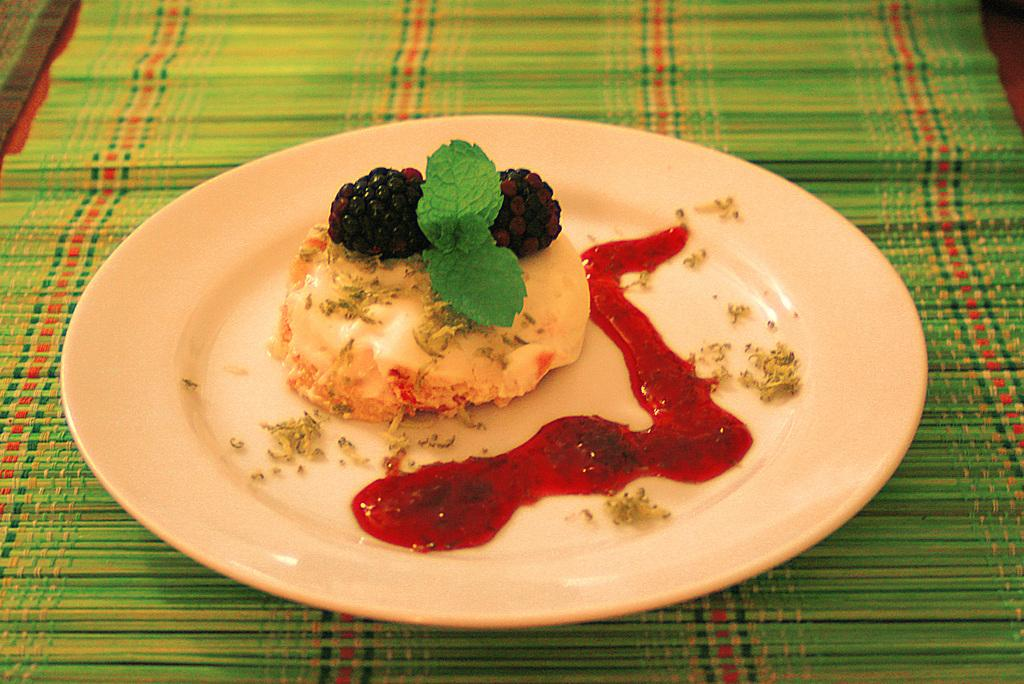What type of landscape is depicted in the image? There is a desert in the image. How is the desert decorated? The desert is decorated with berries. How is the desert served? The desert is served on a plate. What accompanies the desert on the plate? There is sauce beside the desert. What is the plate placed on? The plate is kept on a mat. What type of orange can be seen in the image? There is no orange present in the image; the desert is decorated with berries. How many matches are visible in the image? There are no matches present in the image. 